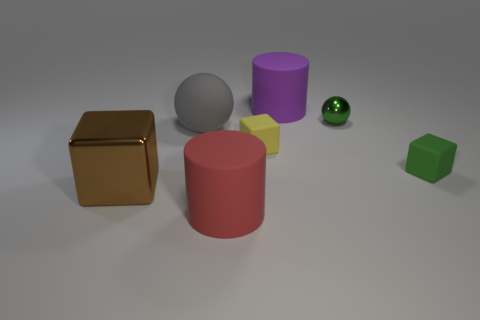Add 2 big brown rubber cylinders. How many objects exist? 9 Subtract all blocks. How many objects are left? 4 Add 5 yellow rubber blocks. How many yellow rubber blocks are left? 6 Add 6 green cylinders. How many green cylinders exist? 6 Subtract 1 brown blocks. How many objects are left? 6 Subtract all small green things. Subtract all large shiny cubes. How many objects are left? 4 